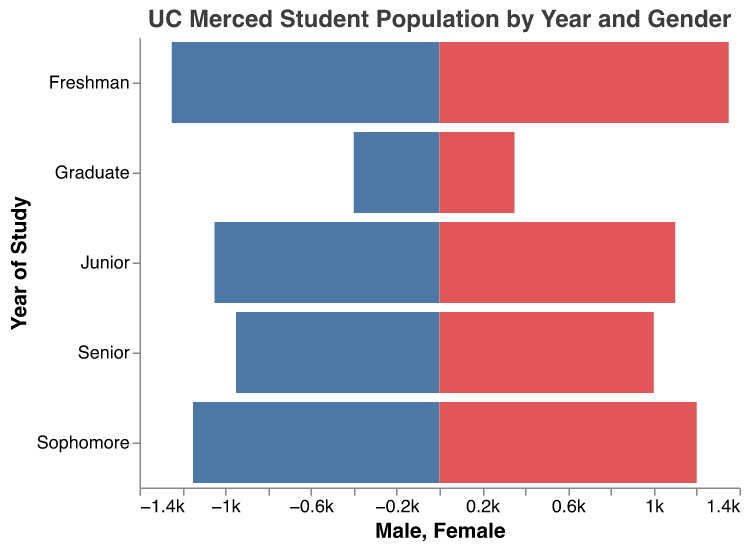How many freshman male students are there? The figure shows the number of freshman male students in one of the bars.
Answer: 1250 Which year has the highest number of female students? Compare the heights of all the bars representing female students for each year. Among Freshman, Sophomore, Junior, Senior, and Graduate, Freshman females have the highest bar.
Answer: Freshman What is the total number of undergraduates? Sum the number of male and female students from Freshman, Sophomore, Junior, and Senior years. The numbers are: Freshman (2600), Sophomore (2350), Junior (2150), and Senior (1950). Total = 2600 + 2350 + 2150 + 1950.
Answer: 9050 How does the number of senior females compare to senior males? Look at the heights of the bars representing senior males and females. Female students are 1000 and male students are 950.
Answer: Female students are more Which gender has more graduate students? Compare the bars representing graduate males and females. The bars show that there are 400 male graduate students and 350 female graduate students.
Answer: Males What is the average number of students in each undergraduate year (both genders combined)? Sum the total number of students for each undergraduate year (Freshman, Sophomore, Junior, Senior), then divide by the number of years. (2600 + 2350 + 2150 + 1950) / 4 = 9050 / 4.
Answer: 2262.5 How many students are there in the junior year? Add the male and female students for the junior year. The numbers are 1050 males and 1100 females. 1050 + 1100 = 2150.
Answer: 2150 What is the ratio of male to female graduate students? Divide the number of male graduate students by the number of female graduate students: 400 males / 350 females = 400/350.
Answer: 400:350 or 8:7 Which year has the lowest total number of students, and what is the number? Compare the total number of students (male + female) for each year: Freshman (2600), Sophomore (2350), Junior (2150), Senior (1950), and Graduate (750). The graduate population is the lowest with 750 students.
Answer: Graduate, 750 Are there more sophomore students than senior students? Compare the total number of sophomore (2350) and senior (1950) students from their respective bars.
Answer: Yes, there are more sophomore students 